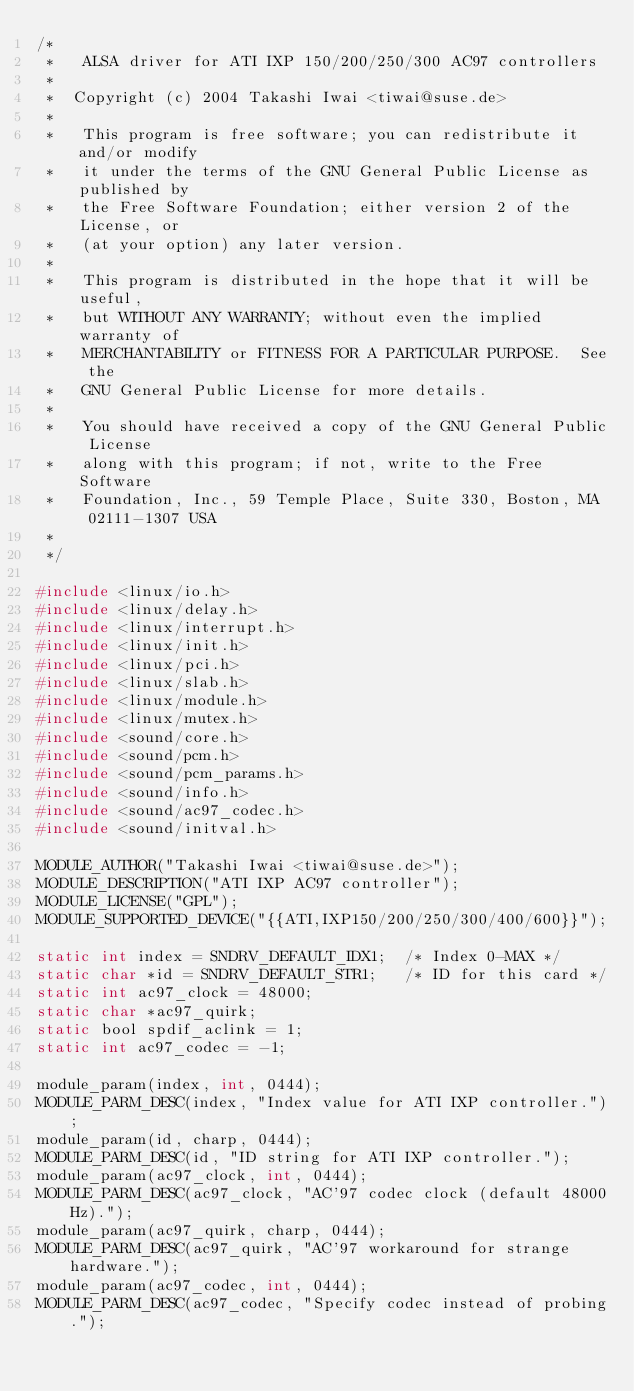<code> <loc_0><loc_0><loc_500><loc_500><_C_>/*
 *   ALSA driver for ATI IXP 150/200/250/300 AC97 controllers
 *
 *	Copyright (c) 2004 Takashi Iwai <tiwai@suse.de>
 *
 *   This program is free software; you can redistribute it and/or modify
 *   it under the terms of the GNU General Public License as published by
 *   the Free Software Foundation; either version 2 of the License, or
 *   (at your option) any later version.
 *
 *   This program is distributed in the hope that it will be useful,
 *   but WITHOUT ANY WARRANTY; without even the implied warranty of
 *   MERCHANTABILITY or FITNESS FOR A PARTICULAR PURPOSE.  See the
 *   GNU General Public License for more details.
 *
 *   You should have received a copy of the GNU General Public License
 *   along with this program; if not, write to the Free Software
 *   Foundation, Inc., 59 Temple Place, Suite 330, Boston, MA  02111-1307 USA
 *
 */

#include <linux/io.h>
#include <linux/delay.h>
#include <linux/interrupt.h>
#include <linux/init.h>
#include <linux/pci.h>
#include <linux/slab.h>
#include <linux/module.h>
#include <linux/mutex.h>
#include <sound/core.h>
#include <sound/pcm.h>
#include <sound/pcm_params.h>
#include <sound/info.h>
#include <sound/ac97_codec.h>
#include <sound/initval.h>

MODULE_AUTHOR("Takashi Iwai <tiwai@suse.de>");
MODULE_DESCRIPTION("ATI IXP AC97 controller");
MODULE_LICENSE("GPL");
MODULE_SUPPORTED_DEVICE("{{ATI,IXP150/200/250/300/400/600}}");

static int index = SNDRV_DEFAULT_IDX1;	/* Index 0-MAX */
static char *id = SNDRV_DEFAULT_STR1;	/* ID for this card */
static int ac97_clock = 48000;
static char *ac97_quirk;
static bool spdif_aclink = 1;
static int ac97_codec = -1;

module_param(index, int, 0444);
MODULE_PARM_DESC(index, "Index value for ATI IXP controller.");
module_param(id, charp, 0444);
MODULE_PARM_DESC(id, "ID string for ATI IXP controller.");
module_param(ac97_clock, int, 0444);
MODULE_PARM_DESC(ac97_clock, "AC'97 codec clock (default 48000Hz).");
module_param(ac97_quirk, charp, 0444);
MODULE_PARM_DESC(ac97_quirk, "AC'97 workaround for strange hardware.");
module_param(ac97_codec, int, 0444);
MODULE_PARM_DESC(ac97_codec, "Specify codec instead of probing.");</code> 